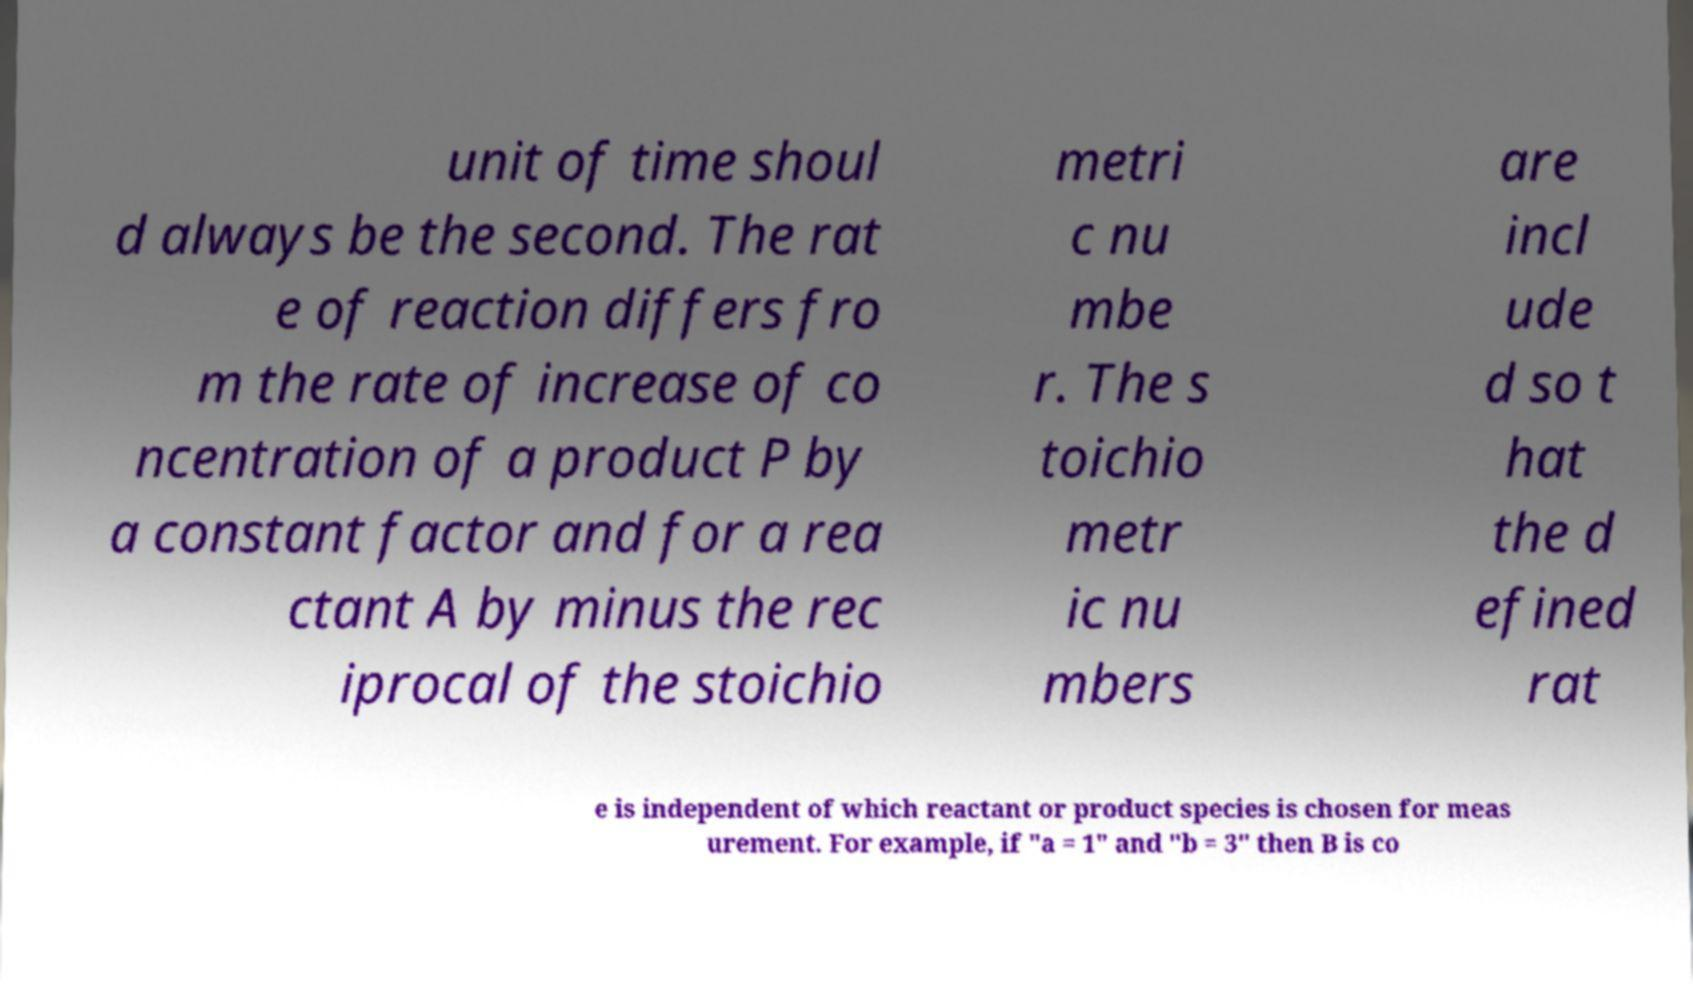There's text embedded in this image that I need extracted. Can you transcribe it verbatim? unit of time shoul d always be the second. The rat e of reaction differs fro m the rate of increase of co ncentration of a product P by a constant factor and for a rea ctant A by minus the rec iprocal of the stoichio metri c nu mbe r. The s toichio metr ic nu mbers are incl ude d so t hat the d efined rat e is independent of which reactant or product species is chosen for meas urement. For example, if "a = 1" and "b = 3" then B is co 